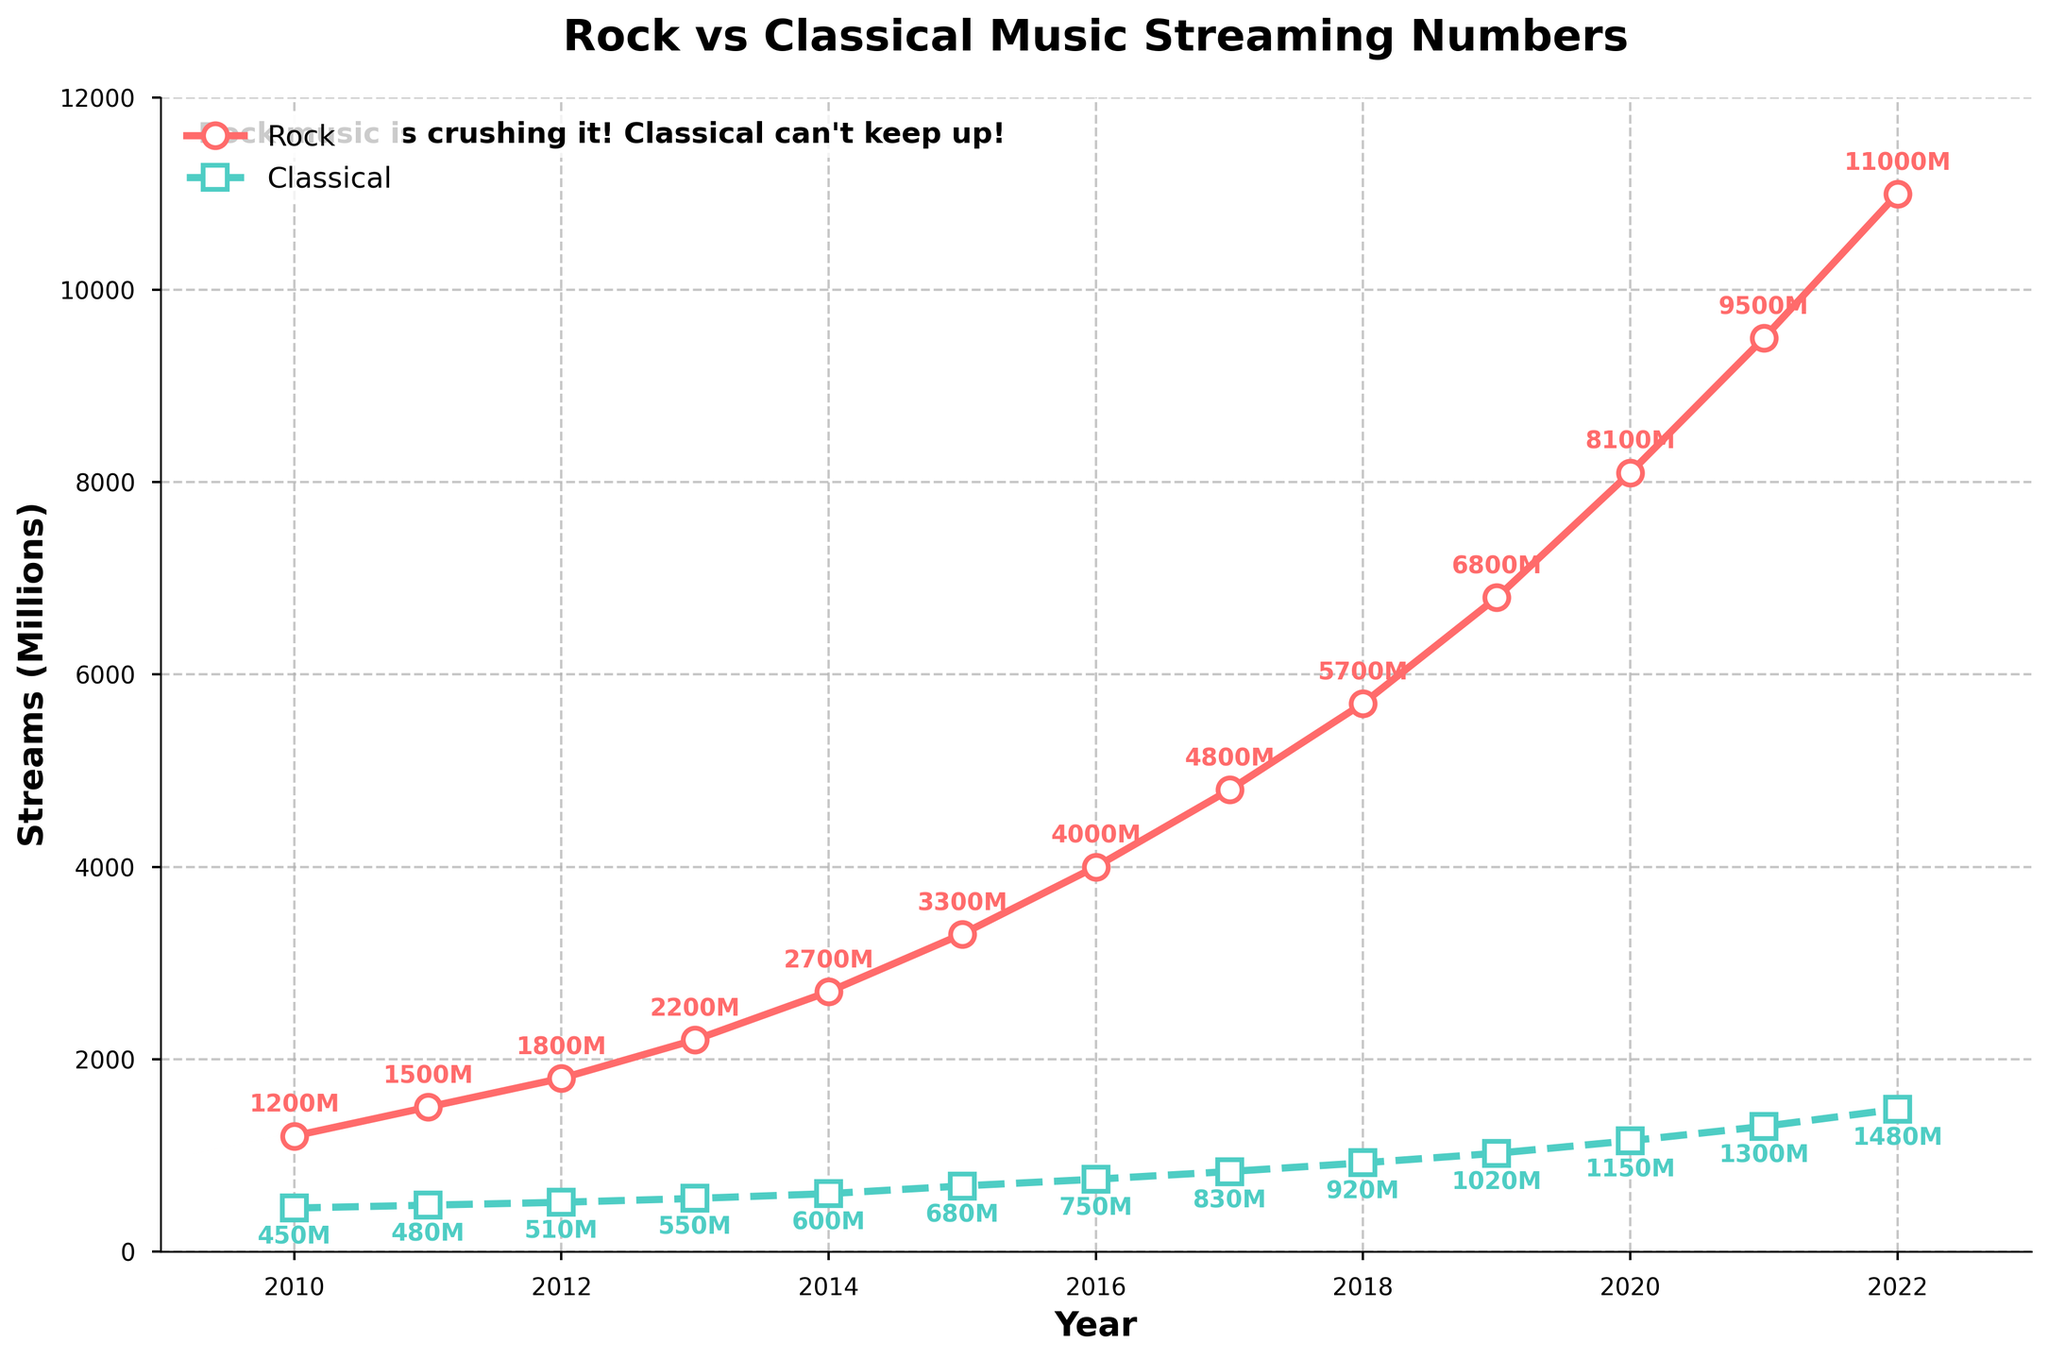What's the percentage increase in rock streams from 2010 to 2015? Find the streams for rock in 2010 (1200M) and in 2015 (3300M). Calculate the difference (3300-1200=2100), then divide by the 2010 value (2100/1200) and multiply by 100 to get the percentage increase.
Answer: 175% In which year did classical music streams first surpass 1000 million? Look at the classical streams data and find the first year where the value is greater than or equal to 1000 million. The value surpasses 1000 million in 2019 (1020M).
Answer: 2019 How many more millions of streams did rock have compared to classical in 2022? Find the streams for rock (11000M) and classical (1480M) in 2022. Subtract the classical streams from the rock streams (11000-1480).
Answer: 9520M Between which two consecutive years did rock music experience the highest absolute increase in streams? Compare the increase in rock streams between each consecutive year pair. The highest increase occurs between 2021 (9500M) and 2022 (11000M) with an increase of (11000-9500=1500).
Answer: 2021-2022 By how much did classical music streams increase from 2010 to 2022? Find the classical streams in 2010 (450M) and in 2022 (1480M). Subtract the 2010 value from the 2022 value (1480-450).
Answer: 1030M 